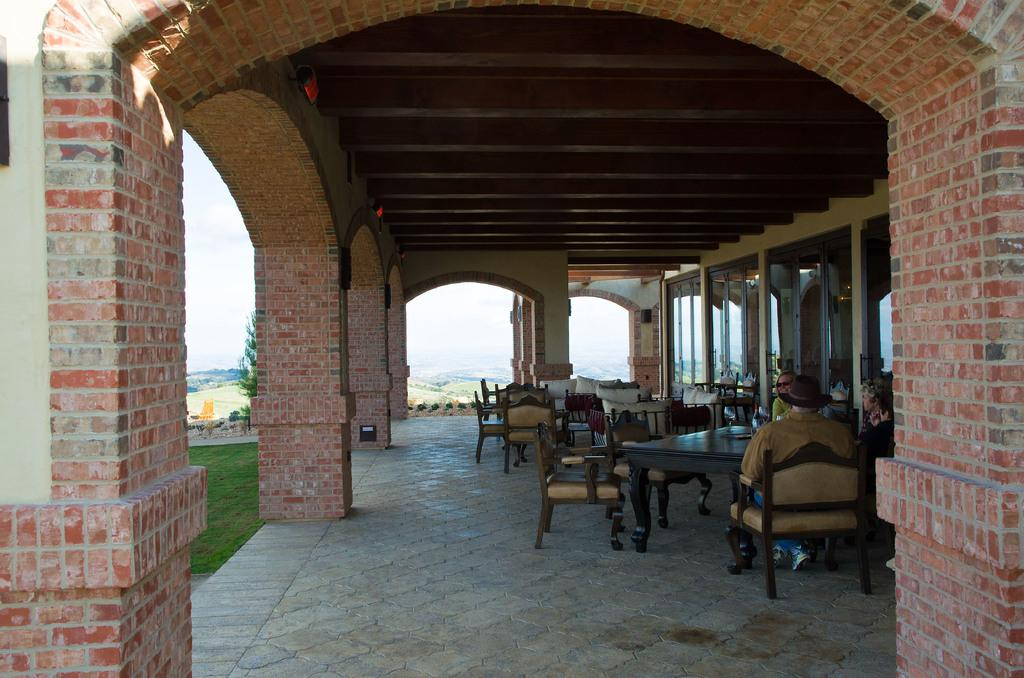What type of building is visible in the image? There is a building with a brick wall in the image. What are the people in the image doing? The people are sitting in front of a table in the image. Where is the table located in the image? The table is on the left side of the image. What can be seen in the background of the image? There are mountains and a clear sky visible in the background of the image. What is the opinion of the building about the disease in the image? There is no indication of a disease or an opinion in the image; it features a building with a brick wall, people sitting at a table, and a background with mountains and a clear sky. 